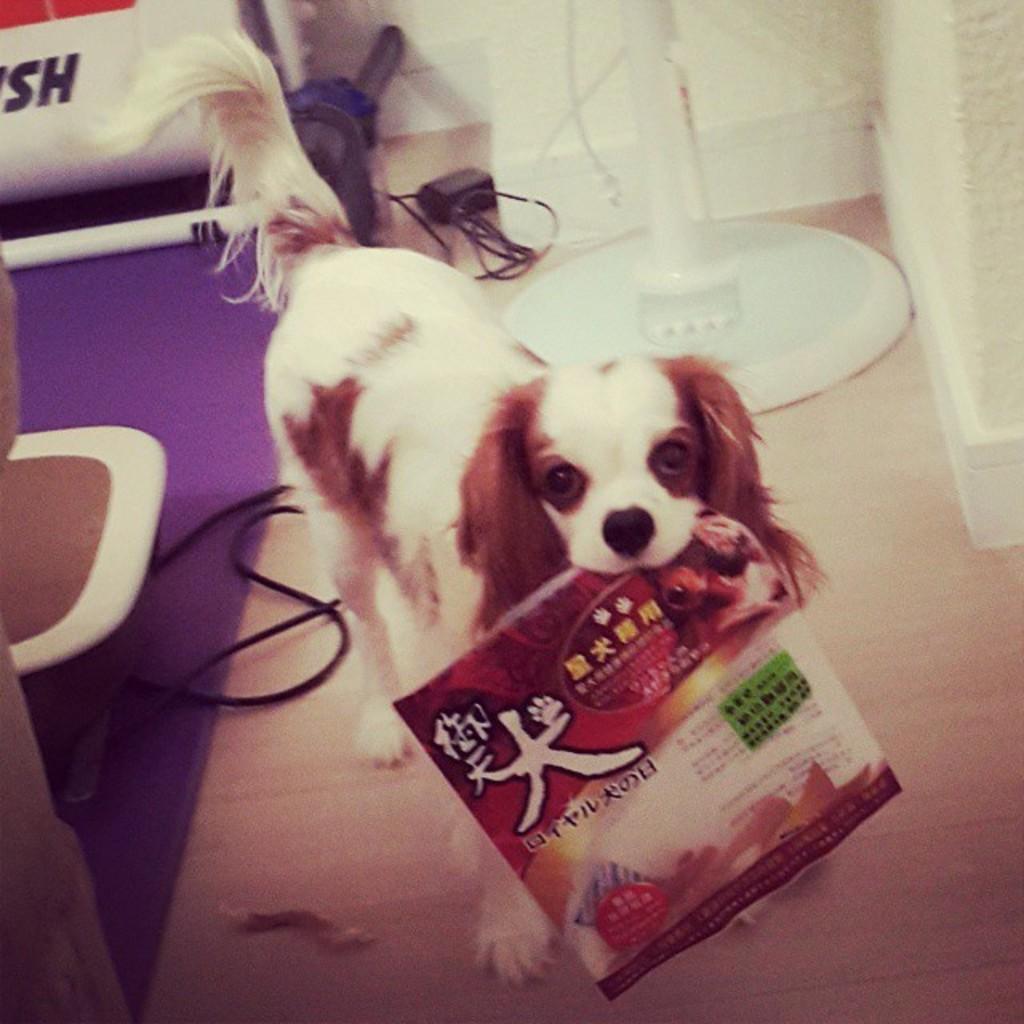Could you give a brief overview of what you see in this image? In this image we can see a dog holding a book with its mouth on the floor. In the background, we can see a stand, group of cables, chairs placed on the floor. 